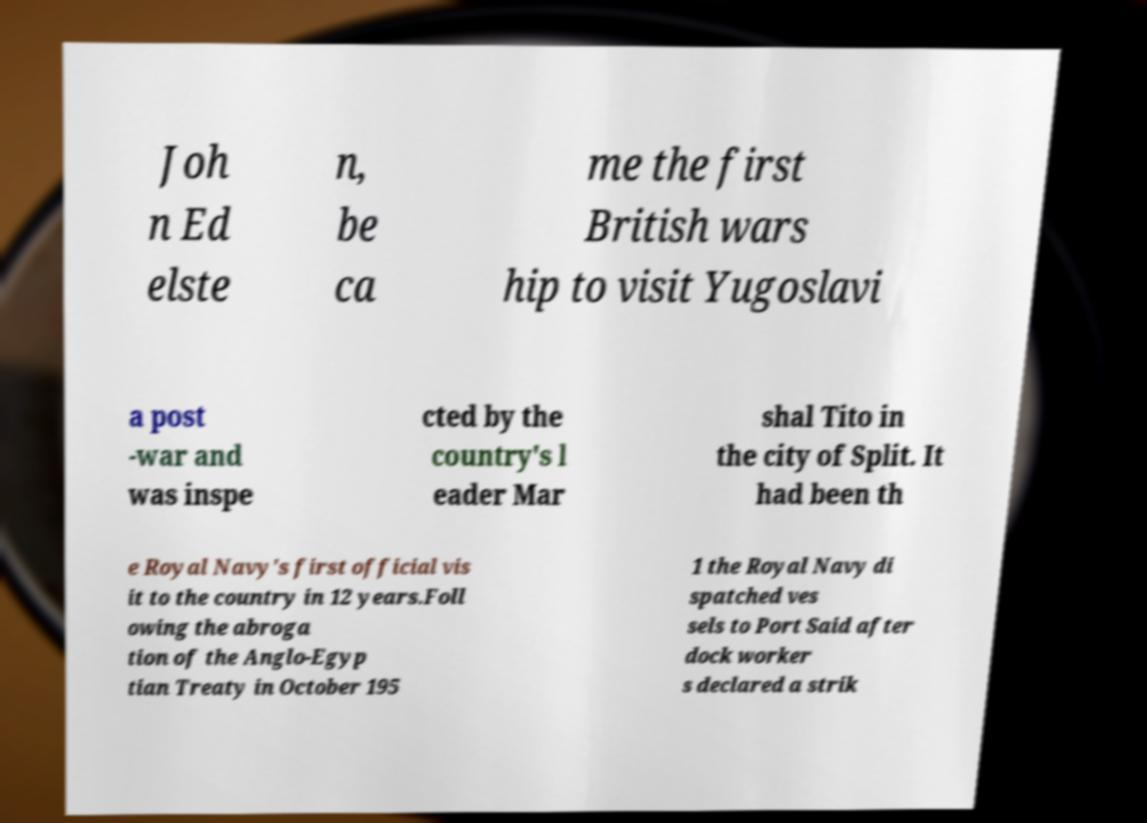I need the written content from this picture converted into text. Can you do that? Joh n Ed elste n, be ca me the first British wars hip to visit Yugoslavi a post -war and was inspe cted by the country's l eader Mar shal Tito in the city of Split. It had been th e Royal Navy's first official vis it to the country in 12 years.Foll owing the abroga tion of the Anglo-Egyp tian Treaty in October 195 1 the Royal Navy di spatched ves sels to Port Said after dock worker s declared a strik 